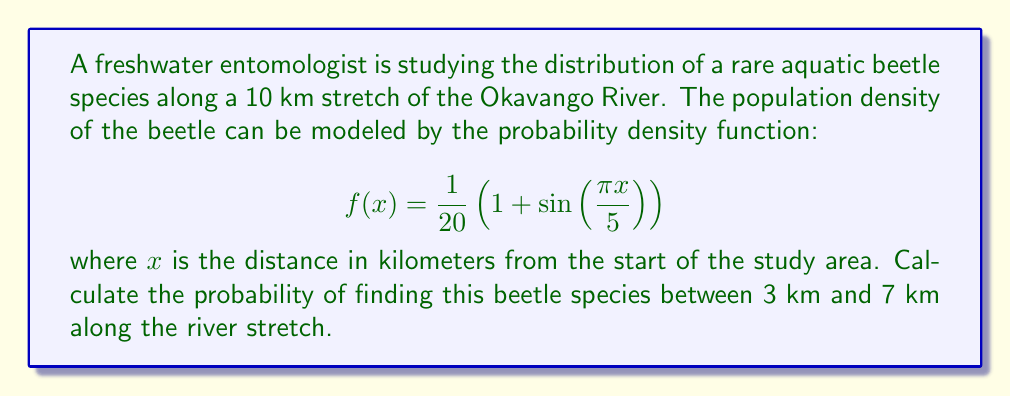Help me with this question. To find the probability of finding the beetle between 3 km and 7 km, we need to integrate the probability density function over this interval:

1) The probability is given by the definite integral:

   $$P(3 \leq X \leq 7) = \int_{3}^{7} f(x) dx$$

2) Substituting our function:

   $$P(3 \leq X \leq 7) = \int_{3}^{7} \frac{1}{20}\left(1 + \sin\left(\frac{\pi x}{5}\right)\right) dx$$

3) Let's break this into two integrals:

   $$P(3 \leq X \leq 7) = \frac{1}{20}\int_{3}^{7} dx + \frac{1}{20}\int_{3}^{7} \sin\left(\frac{\pi x}{5}\right) dx$$

4) The first integral is straightforward:

   $$\frac{1}{20}\int_{3}^{7} dx = \frac{1}{20}[x]_{3}^{7} = \frac{1}{20}(7-3) = \frac{1}{5}$$

5) For the second integral, we use substitution. Let $u = \frac{\pi x}{5}$, then $du = \frac{\pi}{5}dx$, or $dx = \frac{5}{\pi}du$:

   $$\frac{1}{20}\int_{3}^{7} \sin\left(\frac{\pi x}{5}\right) dx = \frac{1}{20} \cdot \frac{5}{\pi}\int_{\frac{3\pi}{5}}^{\frac{7\pi}{5}} \sin(u) du$$

6) Evaluating this integral:

   $$\frac{1}{4\pi}[-\cos(u)]_{\frac{3\pi}{5}}^{\frac{7\pi}{5}} = \frac{1}{4\pi}\left[-\cos\left(\frac{7\pi}{5}\right) + \cos\left(\frac{3\pi}{5}\right)\right]$$

7) Adding the results from steps 4 and 6:

   $$P(3 \leq X \leq 7) = \frac{1}{5} + \frac{1}{4\pi}\left[-\cos\left(\frac{7\pi}{5}\right) + \cos\left(\frac{3\pi}{5}\right)\right]$$

8) Simplifying:

   $$P(3 \leq X \leq 7) = 0.2 + \frac{1}{4\pi}\left[\cos\left(\frac{3\pi}{5}\right) - \cos\left(\frac{7\pi}{5}\right)\right]$$
Answer: $0.2 + \frac{1}{4\pi}\left[\cos\left(\frac{3\pi}{5}\right) - \cos\left(\frac{7\pi}{5}\right)\right]$ 